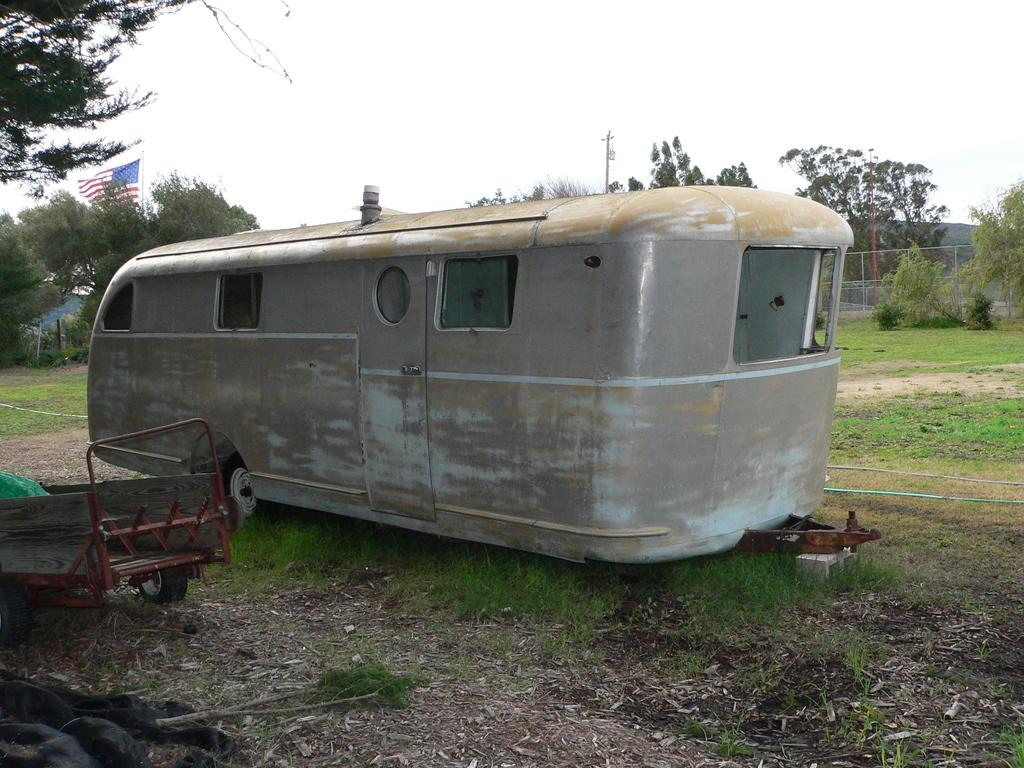Where was the image taken? The image was clicked outside. What can be seen in the middle of the image? There are trees in the middle of the image. What is visible at the top of the image? There is sky visible at the top of the image. What is located on the left side of the image? There is a flag on the left side of the image. What else can be seen in the middle of the image? There is a vehicle in the middle of the image. What type of thread is being used to sew the print on the flag in the image? There is no print on the flag in the image, and therefore no thread can be seen. 